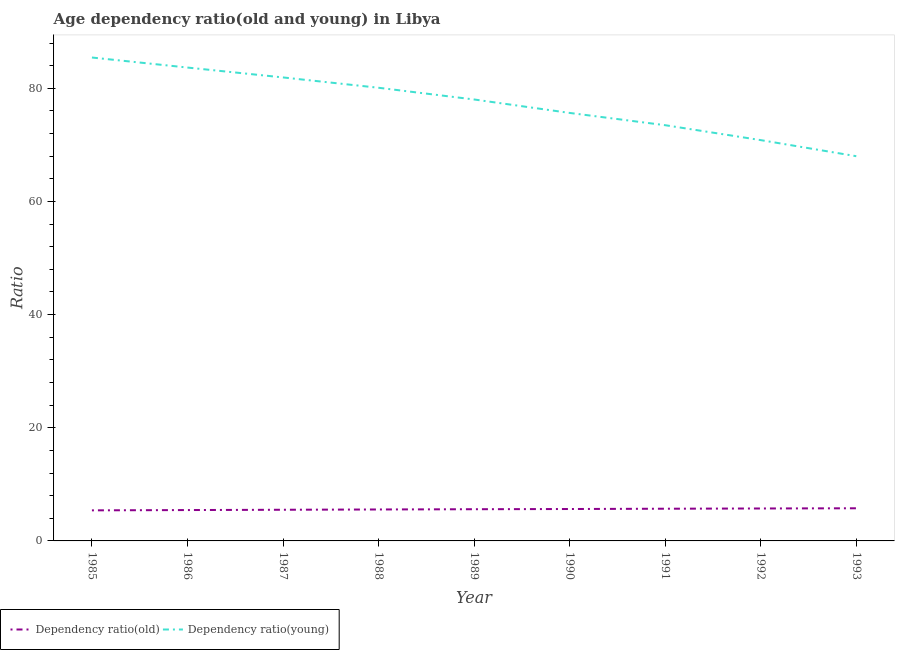How many different coloured lines are there?
Give a very brief answer. 2. Does the line corresponding to age dependency ratio(old) intersect with the line corresponding to age dependency ratio(young)?
Your response must be concise. No. Is the number of lines equal to the number of legend labels?
Make the answer very short. Yes. What is the age dependency ratio(old) in 1986?
Provide a succinct answer. 5.46. Across all years, what is the maximum age dependency ratio(young)?
Ensure brevity in your answer.  85.45. Across all years, what is the minimum age dependency ratio(young)?
Ensure brevity in your answer.  68. What is the total age dependency ratio(young) in the graph?
Offer a terse response. 697.16. What is the difference between the age dependency ratio(old) in 1987 and that in 1992?
Keep it short and to the point. -0.23. What is the difference between the age dependency ratio(young) in 1989 and the age dependency ratio(old) in 1988?
Offer a terse response. 72.47. What is the average age dependency ratio(old) per year?
Keep it short and to the point. 5.6. In the year 1985, what is the difference between the age dependency ratio(old) and age dependency ratio(young)?
Make the answer very short. -80.04. What is the ratio of the age dependency ratio(old) in 1990 to that in 1993?
Your answer should be very brief. 0.98. Is the age dependency ratio(young) in 1988 less than that in 1990?
Provide a succinct answer. No. What is the difference between the highest and the second highest age dependency ratio(young)?
Your response must be concise. 1.77. What is the difference between the highest and the lowest age dependency ratio(old)?
Your answer should be compact. 0.37. In how many years, is the age dependency ratio(old) greater than the average age dependency ratio(old) taken over all years?
Provide a short and direct response. 5. Is the sum of the age dependency ratio(old) in 1990 and 1993 greater than the maximum age dependency ratio(young) across all years?
Keep it short and to the point. No. Does the age dependency ratio(old) monotonically increase over the years?
Make the answer very short. Yes. How many lines are there?
Keep it short and to the point. 2. How many years are there in the graph?
Your answer should be very brief. 9. What is the difference between two consecutive major ticks on the Y-axis?
Offer a very short reply. 20. Does the graph contain any zero values?
Keep it short and to the point. No. How are the legend labels stacked?
Your answer should be very brief. Horizontal. What is the title of the graph?
Give a very brief answer. Age dependency ratio(old and young) in Libya. Does "Under five" appear as one of the legend labels in the graph?
Your answer should be very brief. No. What is the label or title of the Y-axis?
Your response must be concise. Ratio. What is the Ratio in Dependency ratio(old) in 1985?
Your response must be concise. 5.4. What is the Ratio in Dependency ratio(young) in 1985?
Ensure brevity in your answer.  85.45. What is the Ratio in Dependency ratio(old) in 1986?
Make the answer very short. 5.46. What is the Ratio in Dependency ratio(young) in 1986?
Keep it short and to the point. 83.67. What is the Ratio in Dependency ratio(old) in 1987?
Give a very brief answer. 5.51. What is the Ratio in Dependency ratio(young) in 1987?
Ensure brevity in your answer.  81.93. What is the Ratio in Dependency ratio(old) in 1988?
Ensure brevity in your answer.  5.56. What is the Ratio in Dependency ratio(young) in 1988?
Keep it short and to the point. 80.1. What is the Ratio of Dependency ratio(old) in 1989?
Provide a succinct answer. 5.6. What is the Ratio in Dependency ratio(young) in 1989?
Your answer should be compact. 78.03. What is the Ratio of Dependency ratio(old) in 1990?
Provide a short and direct response. 5.64. What is the Ratio of Dependency ratio(young) in 1990?
Ensure brevity in your answer.  75.65. What is the Ratio of Dependency ratio(old) in 1991?
Offer a very short reply. 5.69. What is the Ratio of Dependency ratio(young) in 1991?
Ensure brevity in your answer.  73.48. What is the Ratio of Dependency ratio(old) in 1992?
Offer a terse response. 5.73. What is the Ratio of Dependency ratio(young) in 1992?
Keep it short and to the point. 70.85. What is the Ratio in Dependency ratio(old) in 1993?
Offer a very short reply. 5.77. What is the Ratio of Dependency ratio(young) in 1993?
Make the answer very short. 68. Across all years, what is the maximum Ratio in Dependency ratio(old)?
Offer a terse response. 5.77. Across all years, what is the maximum Ratio of Dependency ratio(young)?
Offer a terse response. 85.45. Across all years, what is the minimum Ratio of Dependency ratio(old)?
Provide a short and direct response. 5.4. Across all years, what is the minimum Ratio in Dependency ratio(young)?
Give a very brief answer. 68. What is the total Ratio of Dependency ratio(old) in the graph?
Your answer should be very brief. 50.37. What is the total Ratio in Dependency ratio(young) in the graph?
Provide a succinct answer. 697.16. What is the difference between the Ratio in Dependency ratio(old) in 1985 and that in 1986?
Ensure brevity in your answer.  -0.05. What is the difference between the Ratio in Dependency ratio(young) in 1985 and that in 1986?
Your response must be concise. 1.77. What is the difference between the Ratio in Dependency ratio(old) in 1985 and that in 1987?
Your response must be concise. -0.11. What is the difference between the Ratio of Dependency ratio(young) in 1985 and that in 1987?
Make the answer very short. 3.52. What is the difference between the Ratio of Dependency ratio(old) in 1985 and that in 1988?
Keep it short and to the point. -0.16. What is the difference between the Ratio in Dependency ratio(young) in 1985 and that in 1988?
Offer a terse response. 5.35. What is the difference between the Ratio in Dependency ratio(old) in 1985 and that in 1989?
Your answer should be compact. -0.2. What is the difference between the Ratio of Dependency ratio(young) in 1985 and that in 1989?
Keep it short and to the point. 7.42. What is the difference between the Ratio in Dependency ratio(old) in 1985 and that in 1990?
Give a very brief answer. -0.24. What is the difference between the Ratio in Dependency ratio(young) in 1985 and that in 1990?
Provide a succinct answer. 9.79. What is the difference between the Ratio in Dependency ratio(old) in 1985 and that in 1991?
Provide a short and direct response. -0.29. What is the difference between the Ratio of Dependency ratio(young) in 1985 and that in 1991?
Offer a very short reply. 11.96. What is the difference between the Ratio of Dependency ratio(old) in 1985 and that in 1992?
Make the answer very short. -0.33. What is the difference between the Ratio in Dependency ratio(young) in 1985 and that in 1992?
Provide a short and direct response. 14.6. What is the difference between the Ratio of Dependency ratio(old) in 1985 and that in 1993?
Offer a very short reply. -0.37. What is the difference between the Ratio in Dependency ratio(young) in 1985 and that in 1993?
Offer a terse response. 17.44. What is the difference between the Ratio in Dependency ratio(old) in 1986 and that in 1987?
Your answer should be compact. -0.05. What is the difference between the Ratio of Dependency ratio(young) in 1986 and that in 1987?
Give a very brief answer. 1.75. What is the difference between the Ratio of Dependency ratio(old) in 1986 and that in 1988?
Your answer should be very brief. -0.1. What is the difference between the Ratio of Dependency ratio(young) in 1986 and that in 1988?
Provide a short and direct response. 3.57. What is the difference between the Ratio in Dependency ratio(old) in 1986 and that in 1989?
Your answer should be very brief. -0.15. What is the difference between the Ratio of Dependency ratio(young) in 1986 and that in 1989?
Your response must be concise. 5.64. What is the difference between the Ratio in Dependency ratio(old) in 1986 and that in 1990?
Keep it short and to the point. -0.19. What is the difference between the Ratio of Dependency ratio(young) in 1986 and that in 1990?
Your response must be concise. 8.02. What is the difference between the Ratio of Dependency ratio(old) in 1986 and that in 1991?
Ensure brevity in your answer.  -0.24. What is the difference between the Ratio of Dependency ratio(young) in 1986 and that in 1991?
Provide a succinct answer. 10.19. What is the difference between the Ratio of Dependency ratio(old) in 1986 and that in 1992?
Provide a short and direct response. -0.28. What is the difference between the Ratio in Dependency ratio(young) in 1986 and that in 1992?
Give a very brief answer. 12.83. What is the difference between the Ratio in Dependency ratio(old) in 1986 and that in 1993?
Your answer should be very brief. -0.32. What is the difference between the Ratio in Dependency ratio(young) in 1986 and that in 1993?
Offer a terse response. 15.67. What is the difference between the Ratio of Dependency ratio(old) in 1987 and that in 1988?
Your response must be concise. -0.05. What is the difference between the Ratio of Dependency ratio(young) in 1987 and that in 1988?
Your answer should be compact. 1.83. What is the difference between the Ratio in Dependency ratio(old) in 1987 and that in 1989?
Make the answer very short. -0.1. What is the difference between the Ratio of Dependency ratio(young) in 1987 and that in 1989?
Make the answer very short. 3.9. What is the difference between the Ratio of Dependency ratio(old) in 1987 and that in 1990?
Keep it short and to the point. -0.13. What is the difference between the Ratio of Dependency ratio(young) in 1987 and that in 1990?
Ensure brevity in your answer.  6.27. What is the difference between the Ratio in Dependency ratio(old) in 1987 and that in 1991?
Make the answer very short. -0.18. What is the difference between the Ratio of Dependency ratio(young) in 1987 and that in 1991?
Offer a terse response. 8.44. What is the difference between the Ratio in Dependency ratio(old) in 1987 and that in 1992?
Offer a terse response. -0.23. What is the difference between the Ratio of Dependency ratio(young) in 1987 and that in 1992?
Offer a very short reply. 11.08. What is the difference between the Ratio in Dependency ratio(old) in 1987 and that in 1993?
Offer a terse response. -0.26. What is the difference between the Ratio of Dependency ratio(young) in 1987 and that in 1993?
Provide a short and direct response. 13.92. What is the difference between the Ratio in Dependency ratio(old) in 1988 and that in 1989?
Ensure brevity in your answer.  -0.04. What is the difference between the Ratio in Dependency ratio(young) in 1988 and that in 1989?
Provide a short and direct response. 2.07. What is the difference between the Ratio of Dependency ratio(old) in 1988 and that in 1990?
Your answer should be very brief. -0.08. What is the difference between the Ratio of Dependency ratio(young) in 1988 and that in 1990?
Your answer should be compact. 4.45. What is the difference between the Ratio in Dependency ratio(old) in 1988 and that in 1991?
Provide a succinct answer. -0.13. What is the difference between the Ratio of Dependency ratio(young) in 1988 and that in 1991?
Make the answer very short. 6.62. What is the difference between the Ratio in Dependency ratio(old) in 1988 and that in 1992?
Give a very brief answer. -0.18. What is the difference between the Ratio of Dependency ratio(young) in 1988 and that in 1992?
Provide a succinct answer. 9.25. What is the difference between the Ratio of Dependency ratio(old) in 1988 and that in 1993?
Your answer should be very brief. -0.21. What is the difference between the Ratio of Dependency ratio(young) in 1988 and that in 1993?
Your response must be concise. 12.1. What is the difference between the Ratio of Dependency ratio(old) in 1989 and that in 1990?
Offer a very short reply. -0.04. What is the difference between the Ratio of Dependency ratio(young) in 1989 and that in 1990?
Make the answer very short. 2.38. What is the difference between the Ratio in Dependency ratio(old) in 1989 and that in 1991?
Give a very brief answer. -0.09. What is the difference between the Ratio in Dependency ratio(young) in 1989 and that in 1991?
Provide a succinct answer. 4.55. What is the difference between the Ratio in Dependency ratio(old) in 1989 and that in 1992?
Provide a short and direct response. -0.13. What is the difference between the Ratio of Dependency ratio(young) in 1989 and that in 1992?
Provide a short and direct response. 7.18. What is the difference between the Ratio of Dependency ratio(old) in 1989 and that in 1993?
Offer a very short reply. -0.17. What is the difference between the Ratio of Dependency ratio(young) in 1989 and that in 1993?
Offer a very short reply. 10.03. What is the difference between the Ratio of Dependency ratio(old) in 1990 and that in 1991?
Make the answer very short. -0.05. What is the difference between the Ratio of Dependency ratio(young) in 1990 and that in 1991?
Your response must be concise. 2.17. What is the difference between the Ratio in Dependency ratio(old) in 1990 and that in 1992?
Your answer should be compact. -0.09. What is the difference between the Ratio of Dependency ratio(young) in 1990 and that in 1992?
Offer a terse response. 4.81. What is the difference between the Ratio of Dependency ratio(old) in 1990 and that in 1993?
Your answer should be very brief. -0.13. What is the difference between the Ratio of Dependency ratio(young) in 1990 and that in 1993?
Your answer should be compact. 7.65. What is the difference between the Ratio of Dependency ratio(old) in 1991 and that in 1992?
Provide a short and direct response. -0.04. What is the difference between the Ratio of Dependency ratio(young) in 1991 and that in 1992?
Your answer should be compact. 2.64. What is the difference between the Ratio in Dependency ratio(old) in 1991 and that in 1993?
Give a very brief answer. -0.08. What is the difference between the Ratio of Dependency ratio(young) in 1991 and that in 1993?
Give a very brief answer. 5.48. What is the difference between the Ratio of Dependency ratio(old) in 1992 and that in 1993?
Your answer should be compact. -0.04. What is the difference between the Ratio in Dependency ratio(young) in 1992 and that in 1993?
Ensure brevity in your answer.  2.84. What is the difference between the Ratio of Dependency ratio(old) in 1985 and the Ratio of Dependency ratio(young) in 1986?
Your answer should be very brief. -78.27. What is the difference between the Ratio in Dependency ratio(old) in 1985 and the Ratio in Dependency ratio(young) in 1987?
Offer a terse response. -76.52. What is the difference between the Ratio in Dependency ratio(old) in 1985 and the Ratio in Dependency ratio(young) in 1988?
Your answer should be compact. -74.7. What is the difference between the Ratio in Dependency ratio(old) in 1985 and the Ratio in Dependency ratio(young) in 1989?
Keep it short and to the point. -72.63. What is the difference between the Ratio in Dependency ratio(old) in 1985 and the Ratio in Dependency ratio(young) in 1990?
Give a very brief answer. -70.25. What is the difference between the Ratio of Dependency ratio(old) in 1985 and the Ratio of Dependency ratio(young) in 1991?
Keep it short and to the point. -68.08. What is the difference between the Ratio in Dependency ratio(old) in 1985 and the Ratio in Dependency ratio(young) in 1992?
Keep it short and to the point. -65.44. What is the difference between the Ratio in Dependency ratio(old) in 1985 and the Ratio in Dependency ratio(young) in 1993?
Your answer should be compact. -62.6. What is the difference between the Ratio in Dependency ratio(old) in 1986 and the Ratio in Dependency ratio(young) in 1987?
Provide a short and direct response. -76.47. What is the difference between the Ratio in Dependency ratio(old) in 1986 and the Ratio in Dependency ratio(young) in 1988?
Offer a very short reply. -74.65. What is the difference between the Ratio of Dependency ratio(old) in 1986 and the Ratio of Dependency ratio(young) in 1989?
Offer a terse response. -72.58. What is the difference between the Ratio of Dependency ratio(old) in 1986 and the Ratio of Dependency ratio(young) in 1990?
Offer a terse response. -70.2. What is the difference between the Ratio in Dependency ratio(old) in 1986 and the Ratio in Dependency ratio(young) in 1991?
Your response must be concise. -68.03. What is the difference between the Ratio in Dependency ratio(old) in 1986 and the Ratio in Dependency ratio(young) in 1992?
Give a very brief answer. -65.39. What is the difference between the Ratio in Dependency ratio(old) in 1986 and the Ratio in Dependency ratio(young) in 1993?
Give a very brief answer. -62.55. What is the difference between the Ratio in Dependency ratio(old) in 1987 and the Ratio in Dependency ratio(young) in 1988?
Keep it short and to the point. -74.59. What is the difference between the Ratio in Dependency ratio(old) in 1987 and the Ratio in Dependency ratio(young) in 1989?
Your response must be concise. -72.52. What is the difference between the Ratio of Dependency ratio(old) in 1987 and the Ratio of Dependency ratio(young) in 1990?
Give a very brief answer. -70.14. What is the difference between the Ratio of Dependency ratio(old) in 1987 and the Ratio of Dependency ratio(young) in 1991?
Offer a terse response. -67.97. What is the difference between the Ratio in Dependency ratio(old) in 1987 and the Ratio in Dependency ratio(young) in 1992?
Offer a terse response. -65.34. What is the difference between the Ratio of Dependency ratio(old) in 1987 and the Ratio of Dependency ratio(young) in 1993?
Your answer should be very brief. -62.5. What is the difference between the Ratio in Dependency ratio(old) in 1988 and the Ratio in Dependency ratio(young) in 1989?
Make the answer very short. -72.47. What is the difference between the Ratio of Dependency ratio(old) in 1988 and the Ratio of Dependency ratio(young) in 1990?
Ensure brevity in your answer.  -70.09. What is the difference between the Ratio in Dependency ratio(old) in 1988 and the Ratio in Dependency ratio(young) in 1991?
Offer a very short reply. -67.92. What is the difference between the Ratio of Dependency ratio(old) in 1988 and the Ratio of Dependency ratio(young) in 1992?
Your answer should be compact. -65.29. What is the difference between the Ratio of Dependency ratio(old) in 1988 and the Ratio of Dependency ratio(young) in 1993?
Ensure brevity in your answer.  -62.45. What is the difference between the Ratio in Dependency ratio(old) in 1989 and the Ratio in Dependency ratio(young) in 1990?
Your answer should be very brief. -70.05. What is the difference between the Ratio of Dependency ratio(old) in 1989 and the Ratio of Dependency ratio(young) in 1991?
Keep it short and to the point. -67.88. What is the difference between the Ratio in Dependency ratio(old) in 1989 and the Ratio in Dependency ratio(young) in 1992?
Keep it short and to the point. -65.24. What is the difference between the Ratio in Dependency ratio(old) in 1989 and the Ratio in Dependency ratio(young) in 1993?
Keep it short and to the point. -62.4. What is the difference between the Ratio of Dependency ratio(old) in 1990 and the Ratio of Dependency ratio(young) in 1991?
Your answer should be very brief. -67.84. What is the difference between the Ratio of Dependency ratio(old) in 1990 and the Ratio of Dependency ratio(young) in 1992?
Provide a succinct answer. -65.21. What is the difference between the Ratio of Dependency ratio(old) in 1990 and the Ratio of Dependency ratio(young) in 1993?
Make the answer very short. -62.36. What is the difference between the Ratio of Dependency ratio(old) in 1991 and the Ratio of Dependency ratio(young) in 1992?
Offer a terse response. -65.15. What is the difference between the Ratio in Dependency ratio(old) in 1991 and the Ratio in Dependency ratio(young) in 1993?
Keep it short and to the point. -62.31. What is the difference between the Ratio in Dependency ratio(old) in 1992 and the Ratio in Dependency ratio(young) in 1993?
Your response must be concise. -62.27. What is the average Ratio of Dependency ratio(old) per year?
Your answer should be compact. 5.6. What is the average Ratio in Dependency ratio(young) per year?
Offer a terse response. 77.46. In the year 1985, what is the difference between the Ratio in Dependency ratio(old) and Ratio in Dependency ratio(young)?
Your answer should be very brief. -80.04. In the year 1986, what is the difference between the Ratio in Dependency ratio(old) and Ratio in Dependency ratio(young)?
Give a very brief answer. -78.22. In the year 1987, what is the difference between the Ratio of Dependency ratio(old) and Ratio of Dependency ratio(young)?
Ensure brevity in your answer.  -76.42. In the year 1988, what is the difference between the Ratio in Dependency ratio(old) and Ratio in Dependency ratio(young)?
Offer a very short reply. -74.54. In the year 1989, what is the difference between the Ratio in Dependency ratio(old) and Ratio in Dependency ratio(young)?
Ensure brevity in your answer.  -72.43. In the year 1990, what is the difference between the Ratio of Dependency ratio(old) and Ratio of Dependency ratio(young)?
Your response must be concise. -70.01. In the year 1991, what is the difference between the Ratio of Dependency ratio(old) and Ratio of Dependency ratio(young)?
Ensure brevity in your answer.  -67.79. In the year 1992, what is the difference between the Ratio in Dependency ratio(old) and Ratio in Dependency ratio(young)?
Provide a short and direct response. -65.11. In the year 1993, what is the difference between the Ratio of Dependency ratio(old) and Ratio of Dependency ratio(young)?
Your answer should be very brief. -62.23. What is the ratio of the Ratio of Dependency ratio(old) in 1985 to that in 1986?
Your answer should be compact. 0.99. What is the ratio of the Ratio in Dependency ratio(young) in 1985 to that in 1986?
Offer a terse response. 1.02. What is the ratio of the Ratio in Dependency ratio(old) in 1985 to that in 1987?
Your answer should be very brief. 0.98. What is the ratio of the Ratio of Dependency ratio(young) in 1985 to that in 1987?
Provide a succinct answer. 1.04. What is the ratio of the Ratio of Dependency ratio(young) in 1985 to that in 1988?
Provide a short and direct response. 1.07. What is the ratio of the Ratio of Dependency ratio(old) in 1985 to that in 1989?
Provide a succinct answer. 0.96. What is the ratio of the Ratio in Dependency ratio(young) in 1985 to that in 1989?
Your answer should be compact. 1.1. What is the ratio of the Ratio in Dependency ratio(old) in 1985 to that in 1990?
Your answer should be very brief. 0.96. What is the ratio of the Ratio in Dependency ratio(young) in 1985 to that in 1990?
Provide a succinct answer. 1.13. What is the ratio of the Ratio in Dependency ratio(old) in 1985 to that in 1991?
Make the answer very short. 0.95. What is the ratio of the Ratio in Dependency ratio(young) in 1985 to that in 1991?
Your answer should be very brief. 1.16. What is the ratio of the Ratio in Dependency ratio(old) in 1985 to that in 1992?
Provide a succinct answer. 0.94. What is the ratio of the Ratio in Dependency ratio(young) in 1985 to that in 1992?
Your response must be concise. 1.21. What is the ratio of the Ratio of Dependency ratio(old) in 1985 to that in 1993?
Provide a short and direct response. 0.94. What is the ratio of the Ratio in Dependency ratio(young) in 1985 to that in 1993?
Provide a short and direct response. 1.26. What is the ratio of the Ratio in Dependency ratio(young) in 1986 to that in 1987?
Ensure brevity in your answer.  1.02. What is the ratio of the Ratio of Dependency ratio(old) in 1986 to that in 1988?
Offer a terse response. 0.98. What is the ratio of the Ratio in Dependency ratio(young) in 1986 to that in 1988?
Provide a succinct answer. 1.04. What is the ratio of the Ratio in Dependency ratio(old) in 1986 to that in 1989?
Offer a terse response. 0.97. What is the ratio of the Ratio in Dependency ratio(young) in 1986 to that in 1989?
Your response must be concise. 1.07. What is the ratio of the Ratio in Dependency ratio(old) in 1986 to that in 1990?
Your response must be concise. 0.97. What is the ratio of the Ratio of Dependency ratio(young) in 1986 to that in 1990?
Provide a succinct answer. 1.11. What is the ratio of the Ratio of Dependency ratio(old) in 1986 to that in 1991?
Give a very brief answer. 0.96. What is the ratio of the Ratio of Dependency ratio(young) in 1986 to that in 1991?
Your answer should be very brief. 1.14. What is the ratio of the Ratio in Dependency ratio(old) in 1986 to that in 1992?
Make the answer very short. 0.95. What is the ratio of the Ratio of Dependency ratio(young) in 1986 to that in 1992?
Ensure brevity in your answer.  1.18. What is the ratio of the Ratio in Dependency ratio(old) in 1986 to that in 1993?
Give a very brief answer. 0.95. What is the ratio of the Ratio in Dependency ratio(young) in 1986 to that in 1993?
Offer a terse response. 1.23. What is the ratio of the Ratio of Dependency ratio(old) in 1987 to that in 1988?
Ensure brevity in your answer.  0.99. What is the ratio of the Ratio of Dependency ratio(young) in 1987 to that in 1988?
Give a very brief answer. 1.02. What is the ratio of the Ratio in Dependency ratio(young) in 1987 to that in 1989?
Give a very brief answer. 1.05. What is the ratio of the Ratio of Dependency ratio(old) in 1987 to that in 1990?
Provide a short and direct response. 0.98. What is the ratio of the Ratio in Dependency ratio(young) in 1987 to that in 1990?
Offer a very short reply. 1.08. What is the ratio of the Ratio of Dependency ratio(old) in 1987 to that in 1991?
Give a very brief answer. 0.97. What is the ratio of the Ratio of Dependency ratio(young) in 1987 to that in 1991?
Offer a very short reply. 1.11. What is the ratio of the Ratio of Dependency ratio(old) in 1987 to that in 1992?
Give a very brief answer. 0.96. What is the ratio of the Ratio in Dependency ratio(young) in 1987 to that in 1992?
Offer a very short reply. 1.16. What is the ratio of the Ratio in Dependency ratio(old) in 1987 to that in 1993?
Your response must be concise. 0.95. What is the ratio of the Ratio of Dependency ratio(young) in 1987 to that in 1993?
Your answer should be very brief. 1.2. What is the ratio of the Ratio of Dependency ratio(old) in 1988 to that in 1989?
Provide a short and direct response. 0.99. What is the ratio of the Ratio in Dependency ratio(young) in 1988 to that in 1989?
Your response must be concise. 1.03. What is the ratio of the Ratio in Dependency ratio(old) in 1988 to that in 1990?
Make the answer very short. 0.99. What is the ratio of the Ratio in Dependency ratio(young) in 1988 to that in 1990?
Make the answer very short. 1.06. What is the ratio of the Ratio in Dependency ratio(old) in 1988 to that in 1991?
Your response must be concise. 0.98. What is the ratio of the Ratio of Dependency ratio(young) in 1988 to that in 1991?
Make the answer very short. 1.09. What is the ratio of the Ratio of Dependency ratio(old) in 1988 to that in 1992?
Keep it short and to the point. 0.97. What is the ratio of the Ratio of Dependency ratio(young) in 1988 to that in 1992?
Your response must be concise. 1.13. What is the ratio of the Ratio of Dependency ratio(old) in 1988 to that in 1993?
Ensure brevity in your answer.  0.96. What is the ratio of the Ratio of Dependency ratio(young) in 1988 to that in 1993?
Provide a succinct answer. 1.18. What is the ratio of the Ratio of Dependency ratio(old) in 1989 to that in 1990?
Provide a succinct answer. 0.99. What is the ratio of the Ratio in Dependency ratio(young) in 1989 to that in 1990?
Your answer should be compact. 1.03. What is the ratio of the Ratio in Dependency ratio(old) in 1989 to that in 1991?
Make the answer very short. 0.98. What is the ratio of the Ratio in Dependency ratio(young) in 1989 to that in 1991?
Your response must be concise. 1.06. What is the ratio of the Ratio in Dependency ratio(old) in 1989 to that in 1992?
Your answer should be very brief. 0.98. What is the ratio of the Ratio in Dependency ratio(young) in 1989 to that in 1992?
Ensure brevity in your answer.  1.1. What is the ratio of the Ratio of Dependency ratio(old) in 1989 to that in 1993?
Give a very brief answer. 0.97. What is the ratio of the Ratio in Dependency ratio(young) in 1989 to that in 1993?
Offer a very short reply. 1.15. What is the ratio of the Ratio in Dependency ratio(old) in 1990 to that in 1991?
Give a very brief answer. 0.99. What is the ratio of the Ratio of Dependency ratio(young) in 1990 to that in 1991?
Provide a succinct answer. 1.03. What is the ratio of the Ratio of Dependency ratio(old) in 1990 to that in 1992?
Offer a terse response. 0.98. What is the ratio of the Ratio in Dependency ratio(young) in 1990 to that in 1992?
Your response must be concise. 1.07. What is the ratio of the Ratio in Dependency ratio(old) in 1990 to that in 1993?
Offer a terse response. 0.98. What is the ratio of the Ratio in Dependency ratio(young) in 1990 to that in 1993?
Offer a very short reply. 1.11. What is the ratio of the Ratio of Dependency ratio(young) in 1991 to that in 1992?
Make the answer very short. 1.04. What is the ratio of the Ratio in Dependency ratio(old) in 1991 to that in 1993?
Your answer should be compact. 0.99. What is the ratio of the Ratio in Dependency ratio(young) in 1991 to that in 1993?
Your answer should be very brief. 1.08. What is the ratio of the Ratio in Dependency ratio(old) in 1992 to that in 1993?
Your answer should be compact. 0.99. What is the ratio of the Ratio in Dependency ratio(young) in 1992 to that in 1993?
Make the answer very short. 1.04. What is the difference between the highest and the second highest Ratio in Dependency ratio(old)?
Keep it short and to the point. 0.04. What is the difference between the highest and the second highest Ratio of Dependency ratio(young)?
Offer a terse response. 1.77. What is the difference between the highest and the lowest Ratio in Dependency ratio(old)?
Keep it short and to the point. 0.37. What is the difference between the highest and the lowest Ratio in Dependency ratio(young)?
Provide a succinct answer. 17.44. 